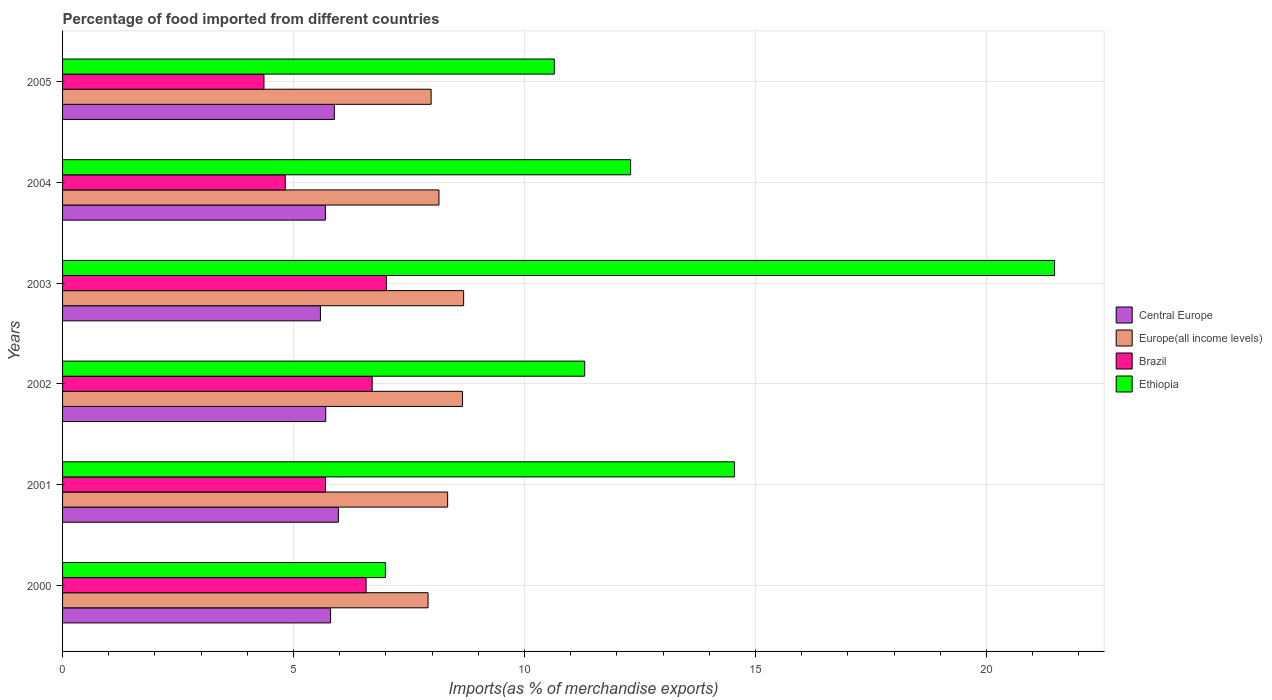How many groups of bars are there?
Keep it short and to the point. 6. Are the number of bars on each tick of the Y-axis equal?
Provide a short and direct response. Yes. How many bars are there on the 4th tick from the top?
Provide a short and direct response. 4. How many bars are there on the 3rd tick from the bottom?
Keep it short and to the point. 4. What is the label of the 4th group of bars from the top?
Make the answer very short. 2002. What is the percentage of imports to different countries in Europe(all income levels) in 2001?
Offer a very short reply. 8.34. Across all years, what is the maximum percentage of imports to different countries in Ethiopia?
Offer a very short reply. 21.47. Across all years, what is the minimum percentage of imports to different countries in Brazil?
Your response must be concise. 4.36. What is the total percentage of imports to different countries in Europe(all income levels) in the graph?
Your answer should be compact. 49.71. What is the difference between the percentage of imports to different countries in Ethiopia in 2002 and that in 2004?
Provide a succinct answer. -0.99. What is the difference between the percentage of imports to different countries in Europe(all income levels) in 2005 and the percentage of imports to different countries in Central Europe in 2000?
Provide a short and direct response. 2.18. What is the average percentage of imports to different countries in Central Europe per year?
Keep it short and to the point. 5.77. In the year 2004, what is the difference between the percentage of imports to different countries in Ethiopia and percentage of imports to different countries in Central Europe?
Keep it short and to the point. 6.61. What is the ratio of the percentage of imports to different countries in Ethiopia in 2001 to that in 2002?
Your answer should be very brief. 1.29. Is the percentage of imports to different countries in Europe(all income levels) in 2002 less than that in 2004?
Provide a short and direct response. No. Is the difference between the percentage of imports to different countries in Ethiopia in 2002 and 2005 greater than the difference between the percentage of imports to different countries in Central Europe in 2002 and 2005?
Ensure brevity in your answer.  Yes. What is the difference between the highest and the second highest percentage of imports to different countries in Europe(all income levels)?
Make the answer very short. 0.03. What is the difference between the highest and the lowest percentage of imports to different countries in Ethiopia?
Provide a succinct answer. 14.49. Is it the case that in every year, the sum of the percentage of imports to different countries in Brazil and percentage of imports to different countries in Ethiopia is greater than the sum of percentage of imports to different countries in Europe(all income levels) and percentage of imports to different countries in Central Europe?
Provide a short and direct response. Yes. What does the 4th bar from the top in 2004 represents?
Offer a terse response. Central Europe. What does the 2nd bar from the bottom in 2004 represents?
Offer a very short reply. Europe(all income levels). Is it the case that in every year, the sum of the percentage of imports to different countries in Europe(all income levels) and percentage of imports to different countries in Brazil is greater than the percentage of imports to different countries in Ethiopia?
Provide a succinct answer. No. Are all the bars in the graph horizontal?
Provide a short and direct response. Yes. How many years are there in the graph?
Offer a terse response. 6. What is the difference between two consecutive major ticks on the X-axis?
Provide a short and direct response. 5. Are the values on the major ticks of X-axis written in scientific E-notation?
Your response must be concise. No. Does the graph contain any zero values?
Provide a succinct answer. No. How many legend labels are there?
Offer a very short reply. 4. What is the title of the graph?
Your answer should be very brief. Percentage of food imported from different countries. What is the label or title of the X-axis?
Ensure brevity in your answer.  Imports(as % of merchandise exports). What is the Imports(as % of merchandise exports) in Central Europe in 2000?
Ensure brevity in your answer.  5.8. What is the Imports(as % of merchandise exports) of Europe(all income levels) in 2000?
Provide a succinct answer. 7.91. What is the Imports(as % of merchandise exports) in Brazil in 2000?
Provide a succinct answer. 6.57. What is the Imports(as % of merchandise exports) in Ethiopia in 2000?
Your answer should be very brief. 6.99. What is the Imports(as % of merchandise exports) in Central Europe in 2001?
Offer a very short reply. 5.97. What is the Imports(as % of merchandise exports) of Europe(all income levels) in 2001?
Your answer should be very brief. 8.34. What is the Imports(as % of merchandise exports) of Brazil in 2001?
Ensure brevity in your answer.  5.69. What is the Imports(as % of merchandise exports) of Ethiopia in 2001?
Keep it short and to the point. 14.55. What is the Imports(as % of merchandise exports) of Central Europe in 2002?
Provide a succinct answer. 5.7. What is the Imports(as % of merchandise exports) in Europe(all income levels) in 2002?
Give a very brief answer. 8.66. What is the Imports(as % of merchandise exports) in Brazil in 2002?
Give a very brief answer. 6.7. What is the Imports(as % of merchandise exports) of Ethiopia in 2002?
Provide a succinct answer. 11.3. What is the Imports(as % of merchandise exports) of Central Europe in 2003?
Keep it short and to the point. 5.58. What is the Imports(as % of merchandise exports) in Europe(all income levels) in 2003?
Offer a very short reply. 8.68. What is the Imports(as % of merchandise exports) of Brazil in 2003?
Offer a very short reply. 7.01. What is the Imports(as % of merchandise exports) of Ethiopia in 2003?
Provide a succinct answer. 21.47. What is the Imports(as % of merchandise exports) in Central Europe in 2004?
Your answer should be compact. 5.69. What is the Imports(as % of merchandise exports) in Europe(all income levels) in 2004?
Offer a very short reply. 8.15. What is the Imports(as % of merchandise exports) of Brazil in 2004?
Keep it short and to the point. 4.82. What is the Imports(as % of merchandise exports) in Ethiopia in 2004?
Ensure brevity in your answer.  12.3. What is the Imports(as % of merchandise exports) of Central Europe in 2005?
Your answer should be compact. 5.88. What is the Imports(as % of merchandise exports) of Europe(all income levels) in 2005?
Offer a very short reply. 7.98. What is the Imports(as % of merchandise exports) of Brazil in 2005?
Provide a short and direct response. 4.36. What is the Imports(as % of merchandise exports) of Ethiopia in 2005?
Give a very brief answer. 10.64. Across all years, what is the maximum Imports(as % of merchandise exports) in Central Europe?
Provide a succinct answer. 5.97. Across all years, what is the maximum Imports(as % of merchandise exports) of Europe(all income levels)?
Make the answer very short. 8.68. Across all years, what is the maximum Imports(as % of merchandise exports) in Brazil?
Your answer should be very brief. 7.01. Across all years, what is the maximum Imports(as % of merchandise exports) in Ethiopia?
Keep it short and to the point. 21.47. Across all years, what is the minimum Imports(as % of merchandise exports) of Central Europe?
Keep it short and to the point. 5.58. Across all years, what is the minimum Imports(as % of merchandise exports) in Europe(all income levels)?
Your response must be concise. 7.91. Across all years, what is the minimum Imports(as % of merchandise exports) of Brazil?
Your answer should be compact. 4.36. Across all years, what is the minimum Imports(as % of merchandise exports) of Ethiopia?
Provide a short and direct response. 6.99. What is the total Imports(as % of merchandise exports) in Central Europe in the graph?
Your answer should be compact. 34.62. What is the total Imports(as % of merchandise exports) in Europe(all income levels) in the graph?
Keep it short and to the point. 49.71. What is the total Imports(as % of merchandise exports) in Brazil in the graph?
Offer a terse response. 35.16. What is the total Imports(as % of merchandise exports) in Ethiopia in the graph?
Make the answer very short. 77.26. What is the difference between the Imports(as % of merchandise exports) of Central Europe in 2000 and that in 2001?
Offer a very short reply. -0.17. What is the difference between the Imports(as % of merchandise exports) in Europe(all income levels) in 2000 and that in 2001?
Your answer should be very brief. -0.42. What is the difference between the Imports(as % of merchandise exports) of Brazil in 2000 and that in 2001?
Offer a terse response. 0.88. What is the difference between the Imports(as % of merchandise exports) of Ethiopia in 2000 and that in 2001?
Offer a very short reply. -7.56. What is the difference between the Imports(as % of merchandise exports) in Central Europe in 2000 and that in 2002?
Offer a terse response. 0.1. What is the difference between the Imports(as % of merchandise exports) of Europe(all income levels) in 2000 and that in 2002?
Provide a short and direct response. -0.74. What is the difference between the Imports(as % of merchandise exports) in Brazil in 2000 and that in 2002?
Give a very brief answer. -0.13. What is the difference between the Imports(as % of merchandise exports) of Ethiopia in 2000 and that in 2002?
Your answer should be very brief. -4.31. What is the difference between the Imports(as % of merchandise exports) of Central Europe in 2000 and that in 2003?
Keep it short and to the point. 0.22. What is the difference between the Imports(as % of merchandise exports) of Europe(all income levels) in 2000 and that in 2003?
Your response must be concise. -0.77. What is the difference between the Imports(as % of merchandise exports) in Brazil in 2000 and that in 2003?
Keep it short and to the point. -0.44. What is the difference between the Imports(as % of merchandise exports) of Ethiopia in 2000 and that in 2003?
Offer a very short reply. -14.49. What is the difference between the Imports(as % of merchandise exports) of Central Europe in 2000 and that in 2004?
Ensure brevity in your answer.  0.11. What is the difference between the Imports(as % of merchandise exports) of Europe(all income levels) in 2000 and that in 2004?
Offer a terse response. -0.24. What is the difference between the Imports(as % of merchandise exports) in Brazil in 2000 and that in 2004?
Provide a succinct answer. 1.75. What is the difference between the Imports(as % of merchandise exports) in Ethiopia in 2000 and that in 2004?
Your answer should be very brief. -5.31. What is the difference between the Imports(as % of merchandise exports) in Central Europe in 2000 and that in 2005?
Offer a very short reply. -0.08. What is the difference between the Imports(as % of merchandise exports) of Europe(all income levels) in 2000 and that in 2005?
Ensure brevity in your answer.  -0.07. What is the difference between the Imports(as % of merchandise exports) of Brazil in 2000 and that in 2005?
Give a very brief answer. 2.21. What is the difference between the Imports(as % of merchandise exports) in Ethiopia in 2000 and that in 2005?
Keep it short and to the point. -3.66. What is the difference between the Imports(as % of merchandise exports) of Central Europe in 2001 and that in 2002?
Your answer should be very brief. 0.27. What is the difference between the Imports(as % of merchandise exports) in Europe(all income levels) in 2001 and that in 2002?
Offer a terse response. -0.32. What is the difference between the Imports(as % of merchandise exports) of Brazil in 2001 and that in 2002?
Offer a terse response. -1.01. What is the difference between the Imports(as % of merchandise exports) in Ethiopia in 2001 and that in 2002?
Ensure brevity in your answer.  3.24. What is the difference between the Imports(as % of merchandise exports) in Central Europe in 2001 and that in 2003?
Your answer should be compact. 0.39. What is the difference between the Imports(as % of merchandise exports) of Europe(all income levels) in 2001 and that in 2003?
Provide a short and direct response. -0.35. What is the difference between the Imports(as % of merchandise exports) of Brazil in 2001 and that in 2003?
Make the answer very short. -1.32. What is the difference between the Imports(as % of merchandise exports) of Ethiopia in 2001 and that in 2003?
Your answer should be very brief. -6.93. What is the difference between the Imports(as % of merchandise exports) of Central Europe in 2001 and that in 2004?
Your answer should be compact. 0.28. What is the difference between the Imports(as % of merchandise exports) in Europe(all income levels) in 2001 and that in 2004?
Offer a very short reply. 0.19. What is the difference between the Imports(as % of merchandise exports) of Brazil in 2001 and that in 2004?
Provide a succinct answer. 0.87. What is the difference between the Imports(as % of merchandise exports) of Ethiopia in 2001 and that in 2004?
Your response must be concise. 2.25. What is the difference between the Imports(as % of merchandise exports) in Central Europe in 2001 and that in 2005?
Offer a terse response. 0.09. What is the difference between the Imports(as % of merchandise exports) of Europe(all income levels) in 2001 and that in 2005?
Provide a short and direct response. 0.36. What is the difference between the Imports(as % of merchandise exports) of Brazil in 2001 and that in 2005?
Your response must be concise. 1.33. What is the difference between the Imports(as % of merchandise exports) of Ethiopia in 2001 and that in 2005?
Your answer should be compact. 3.9. What is the difference between the Imports(as % of merchandise exports) in Central Europe in 2002 and that in 2003?
Offer a terse response. 0.12. What is the difference between the Imports(as % of merchandise exports) in Europe(all income levels) in 2002 and that in 2003?
Your answer should be very brief. -0.03. What is the difference between the Imports(as % of merchandise exports) of Brazil in 2002 and that in 2003?
Give a very brief answer. -0.31. What is the difference between the Imports(as % of merchandise exports) in Ethiopia in 2002 and that in 2003?
Make the answer very short. -10.17. What is the difference between the Imports(as % of merchandise exports) of Central Europe in 2002 and that in 2004?
Your response must be concise. 0.01. What is the difference between the Imports(as % of merchandise exports) in Europe(all income levels) in 2002 and that in 2004?
Give a very brief answer. 0.51. What is the difference between the Imports(as % of merchandise exports) of Brazil in 2002 and that in 2004?
Offer a very short reply. 1.88. What is the difference between the Imports(as % of merchandise exports) of Ethiopia in 2002 and that in 2004?
Your answer should be compact. -0.99. What is the difference between the Imports(as % of merchandise exports) of Central Europe in 2002 and that in 2005?
Keep it short and to the point. -0.19. What is the difference between the Imports(as % of merchandise exports) in Europe(all income levels) in 2002 and that in 2005?
Your answer should be compact. 0.68. What is the difference between the Imports(as % of merchandise exports) in Brazil in 2002 and that in 2005?
Ensure brevity in your answer.  2.34. What is the difference between the Imports(as % of merchandise exports) in Ethiopia in 2002 and that in 2005?
Make the answer very short. 0.66. What is the difference between the Imports(as % of merchandise exports) in Central Europe in 2003 and that in 2004?
Provide a succinct answer. -0.11. What is the difference between the Imports(as % of merchandise exports) in Europe(all income levels) in 2003 and that in 2004?
Offer a very short reply. 0.53. What is the difference between the Imports(as % of merchandise exports) of Brazil in 2003 and that in 2004?
Offer a very short reply. 2.19. What is the difference between the Imports(as % of merchandise exports) in Ethiopia in 2003 and that in 2004?
Keep it short and to the point. 9.18. What is the difference between the Imports(as % of merchandise exports) in Central Europe in 2003 and that in 2005?
Provide a short and direct response. -0.3. What is the difference between the Imports(as % of merchandise exports) in Europe(all income levels) in 2003 and that in 2005?
Give a very brief answer. 0.7. What is the difference between the Imports(as % of merchandise exports) in Brazil in 2003 and that in 2005?
Your answer should be very brief. 2.65. What is the difference between the Imports(as % of merchandise exports) in Ethiopia in 2003 and that in 2005?
Keep it short and to the point. 10.83. What is the difference between the Imports(as % of merchandise exports) in Central Europe in 2004 and that in 2005?
Provide a short and direct response. -0.19. What is the difference between the Imports(as % of merchandise exports) in Europe(all income levels) in 2004 and that in 2005?
Keep it short and to the point. 0.17. What is the difference between the Imports(as % of merchandise exports) in Brazil in 2004 and that in 2005?
Give a very brief answer. 0.46. What is the difference between the Imports(as % of merchandise exports) of Ethiopia in 2004 and that in 2005?
Provide a short and direct response. 1.65. What is the difference between the Imports(as % of merchandise exports) in Central Europe in 2000 and the Imports(as % of merchandise exports) in Europe(all income levels) in 2001?
Make the answer very short. -2.53. What is the difference between the Imports(as % of merchandise exports) of Central Europe in 2000 and the Imports(as % of merchandise exports) of Brazil in 2001?
Provide a succinct answer. 0.11. What is the difference between the Imports(as % of merchandise exports) in Central Europe in 2000 and the Imports(as % of merchandise exports) in Ethiopia in 2001?
Your answer should be very brief. -8.74. What is the difference between the Imports(as % of merchandise exports) in Europe(all income levels) in 2000 and the Imports(as % of merchandise exports) in Brazil in 2001?
Your answer should be compact. 2.22. What is the difference between the Imports(as % of merchandise exports) in Europe(all income levels) in 2000 and the Imports(as % of merchandise exports) in Ethiopia in 2001?
Keep it short and to the point. -6.63. What is the difference between the Imports(as % of merchandise exports) of Brazil in 2000 and the Imports(as % of merchandise exports) of Ethiopia in 2001?
Make the answer very short. -7.98. What is the difference between the Imports(as % of merchandise exports) in Central Europe in 2000 and the Imports(as % of merchandise exports) in Europe(all income levels) in 2002?
Ensure brevity in your answer.  -2.85. What is the difference between the Imports(as % of merchandise exports) of Central Europe in 2000 and the Imports(as % of merchandise exports) of Brazil in 2002?
Keep it short and to the point. -0.9. What is the difference between the Imports(as % of merchandise exports) of Central Europe in 2000 and the Imports(as % of merchandise exports) of Ethiopia in 2002?
Your answer should be very brief. -5.5. What is the difference between the Imports(as % of merchandise exports) of Europe(all income levels) in 2000 and the Imports(as % of merchandise exports) of Brazil in 2002?
Give a very brief answer. 1.21. What is the difference between the Imports(as % of merchandise exports) in Europe(all income levels) in 2000 and the Imports(as % of merchandise exports) in Ethiopia in 2002?
Offer a terse response. -3.39. What is the difference between the Imports(as % of merchandise exports) of Brazil in 2000 and the Imports(as % of merchandise exports) of Ethiopia in 2002?
Provide a succinct answer. -4.73. What is the difference between the Imports(as % of merchandise exports) in Central Europe in 2000 and the Imports(as % of merchandise exports) in Europe(all income levels) in 2003?
Offer a terse response. -2.88. What is the difference between the Imports(as % of merchandise exports) in Central Europe in 2000 and the Imports(as % of merchandise exports) in Brazil in 2003?
Your answer should be compact. -1.21. What is the difference between the Imports(as % of merchandise exports) of Central Europe in 2000 and the Imports(as % of merchandise exports) of Ethiopia in 2003?
Give a very brief answer. -15.67. What is the difference between the Imports(as % of merchandise exports) of Europe(all income levels) in 2000 and the Imports(as % of merchandise exports) of Brazil in 2003?
Your response must be concise. 0.9. What is the difference between the Imports(as % of merchandise exports) of Europe(all income levels) in 2000 and the Imports(as % of merchandise exports) of Ethiopia in 2003?
Provide a succinct answer. -13.56. What is the difference between the Imports(as % of merchandise exports) of Brazil in 2000 and the Imports(as % of merchandise exports) of Ethiopia in 2003?
Give a very brief answer. -14.9. What is the difference between the Imports(as % of merchandise exports) in Central Europe in 2000 and the Imports(as % of merchandise exports) in Europe(all income levels) in 2004?
Offer a very short reply. -2.35. What is the difference between the Imports(as % of merchandise exports) in Central Europe in 2000 and the Imports(as % of merchandise exports) in Brazil in 2004?
Provide a short and direct response. 0.98. What is the difference between the Imports(as % of merchandise exports) in Central Europe in 2000 and the Imports(as % of merchandise exports) in Ethiopia in 2004?
Provide a succinct answer. -6.5. What is the difference between the Imports(as % of merchandise exports) of Europe(all income levels) in 2000 and the Imports(as % of merchandise exports) of Brazil in 2004?
Ensure brevity in your answer.  3.09. What is the difference between the Imports(as % of merchandise exports) of Europe(all income levels) in 2000 and the Imports(as % of merchandise exports) of Ethiopia in 2004?
Ensure brevity in your answer.  -4.39. What is the difference between the Imports(as % of merchandise exports) in Brazil in 2000 and the Imports(as % of merchandise exports) in Ethiopia in 2004?
Your answer should be very brief. -5.73. What is the difference between the Imports(as % of merchandise exports) of Central Europe in 2000 and the Imports(as % of merchandise exports) of Europe(all income levels) in 2005?
Your response must be concise. -2.18. What is the difference between the Imports(as % of merchandise exports) of Central Europe in 2000 and the Imports(as % of merchandise exports) of Brazil in 2005?
Make the answer very short. 1.44. What is the difference between the Imports(as % of merchandise exports) of Central Europe in 2000 and the Imports(as % of merchandise exports) of Ethiopia in 2005?
Your answer should be very brief. -4.84. What is the difference between the Imports(as % of merchandise exports) in Europe(all income levels) in 2000 and the Imports(as % of merchandise exports) in Brazil in 2005?
Provide a short and direct response. 3.55. What is the difference between the Imports(as % of merchandise exports) of Europe(all income levels) in 2000 and the Imports(as % of merchandise exports) of Ethiopia in 2005?
Your response must be concise. -2.73. What is the difference between the Imports(as % of merchandise exports) in Brazil in 2000 and the Imports(as % of merchandise exports) in Ethiopia in 2005?
Offer a terse response. -4.07. What is the difference between the Imports(as % of merchandise exports) in Central Europe in 2001 and the Imports(as % of merchandise exports) in Europe(all income levels) in 2002?
Provide a succinct answer. -2.69. What is the difference between the Imports(as % of merchandise exports) in Central Europe in 2001 and the Imports(as % of merchandise exports) in Brazil in 2002?
Provide a short and direct response. -0.73. What is the difference between the Imports(as % of merchandise exports) of Central Europe in 2001 and the Imports(as % of merchandise exports) of Ethiopia in 2002?
Ensure brevity in your answer.  -5.33. What is the difference between the Imports(as % of merchandise exports) of Europe(all income levels) in 2001 and the Imports(as % of merchandise exports) of Brazil in 2002?
Your answer should be very brief. 1.63. What is the difference between the Imports(as % of merchandise exports) of Europe(all income levels) in 2001 and the Imports(as % of merchandise exports) of Ethiopia in 2002?
Provide a succinct answer. -2.97. What is the difference between the Imports(as % of merchandise exports) of Brazil in 2001 and the Imports(as % of merchandise exports) of Ethiopia in 2002?
Offer a terse response. -5.61. What is the difference between the Imports(as % of merchandise exports) in Central Europe in 2001 and the Imports(as % of merchandise exports) in Europe(all income levels) in 2003?
Keep it short and to the point. -2.71. What is the difference between the Imports(as % of merchandise exports) in Central Europe in 2001 and the Imports(as % of merchandise exports) in Brazil in 2003?
Your answer should be compact. -1.04. What is the difference between the Imports(as % of merchandise exports) in Central Europe in 2001 and the Imports(as % of merchandise exports) in Ethiopia in 2003?
Your answer should be compact. -15.5. What is the difference between the Imports(as % of merchandise exports) in Europe(all income levels) in 2001 and the Imports(as % of merchandise exports) in Brazil in 2003?
Your answer should be compact. 1.33. What is the difference between the Imports(as % of merchandise exports) of Europe(all income levels) in 2001 and the Imports(as % of merchandise exports) of Ethiopia in 2003?
Offer a terse response. -13.14. What is the difference between the Imports(as % of merchandise exports) of Brazil in 2001 and the Imports(as % of merchandise exports) of Ethiopia in 2003?
Your answer should be compact. -15.78. What is the difference between the Imports(as % of merchandise exports) in Central Europe in 2001 and the Imports(as % of merchandise exports) in Europe(all income levels) in 2004?
Your response must be concise. -2.18. What is the difference between the Imports(as % of merchandise exports) of Central Europe in 2001 and the Imports(as % of merchandise exports) of Brazil in 2004?
Make the answer very short. 1.15. What is the difference between the Imports(as % of merchandise exports) in Central Europe in 2001 and the Imports(as % of merchandise exports) in Ethiopia in 2004?
Ensure brevity in your answer.  -6.33. What is the difference between the Imports(as % of merchandise exports) in Europe(all income levels) in 2001 and the Imports(as % of merchandise exports) in Brazil in 2004?
Provide a succinct answer. 3.52. What is the difference between the Imports(as % of merchandise exports) in Europe(all income levels) in 2001 and the Imports(as % of merchandise exports) in Ethiopia in 2004?
Ensure brevity in your answer.  -3.96. What is the difference between the Imports(as % of merchandise exports) in Brazil in 2001 and the Imports(as % of merchandise exports) in Ethiopia in 2004?
Ensure brevity in your answer.  -6.61. What is the difference between the Imports(as % of merchandise exports) in Central Europe in 2001 and the Imports(as % of merchandise exports) in Europe(all income levels) in 2005?
Provide a short and direct response. -2.01. What is the difference between the Imports(as % of merchandise exports) of Central Europe in 2001 and the Imports(as % of merchandise exports) of Brazil in 2005?
Make the answer very short. 1.61. What is the difference between the Imports(as % of merchandise exports) in Central Europe in 2001 and the Imports(as % of merchandise exports) in Ethiopia in 2005?
Provide a succinct answer. -4.67. What is the difference between the Imports(as % of merchandise exports) in Europe(all income levels) in 2001 and the Imports(as % of merchandise exports) in Brazil in 2005?
Give a very brief answer. 3.98. What is the difference between the Imports(as % of merchandise exports) in Europe(all income levels) in 2001 and the Imports(as % of merchandise exports) in Ethiopia in 2005?
Provide a short and direct response. -2.31. What is the difference between the Imports(as % of merchandise exports) in Brazil in 2001 and the Imports(as % of merchandise exports) in Ethiopia in 2005?
Your response must be concise. -4.95. What is the difference between the Imports(as % of merchandise exports) of Central Europe in 2002 and the Imports(as % of merchandise exports) of Europe(all income levels) in 2003?
Give a very brief answer. -2.98. What is the difference between the Imports(as % of merchandise exports) in Central Europe in 2002 and the Imports(as % of merchandise exports) in Brazil in 2003?
Your response must be concise. -1.31. What is the difference between the Imports(as % of merchandise exports) of Central Europe in 2002 and the Imports(as % of merchandise exports) of Ethiopia in 2003?
Your response must be concise. -15.78. What is the difference between the Imports(as % of merchandise exports) of Europe(all income levels) in 2002 and the Imports(as % of merchandise exports) of Brazil in 2003?
Your answer should be compact. 1.65. What is the difference between the Imports(as % of merchandise exports) of Europe(all income levels) in 2002 and the Imports(as % of merchandise exports) of Ethiopia in 2003?
Your answer should be compact. -12.82. What is the difference between the Imports(as % of merchandise exports) in Brazil in 2002 and the Imports(as % of merchandise exports) in Ethiopia in 2003?
Offer a very short reply. -14.77. What is the difference between the Imports(as % of merchandise exports) of Central Europe in 2002 and the Imports(as % of merchandise exports) of Europe(all income levels) in 2004?
Offer a terse response. -2.45. What is the difference between the Imports(as % of merchandise exports) of Central Europe in 2002 and the Imports(as % of merchandise exports) of Brazil in 2004?
Your response must be concise. 0.88. What is the difference between the Imports(as % of merchandise exports) of Central Europe in 2002 and the Imports(as % of merchandise exports) of Ethiopia in 2004?
Provide a short and direct response. -6.6. What is the difference between the Imports(as % of merchandise exports) in Europe(all income levels) in 2002 and the Imports(as % of merchandise exports) in Brazil in 2004?
Ensure brevity in your answer.  3.84. What is the difference between the Imports(as % of merchandise exports) of Europe(all income levels) in 2002 and the Imports(as % of merchandise exports) of Ethiopia in 2004?
Give a very brief answer. -3.64. What is the difference between the Imports(as % of merchandise exports) of Brazil in 2002 and the Imports(as % of merchandise exports) of Ethiopia in 2004?
Your response must be concise. -5.59. What is the difference between the Imports(as % of merchandise exports) of Central Europe in 2002 and the Imports(as % of merchandise exports) of Europe(all income levels) in 2005?
Keep it short and to the point. -2.28. What is the difference between the Imports(as % of merchandise exports) in Central Europe in 2002 and the Imports(as % of merchandise exports) in Brazil in 2005?
Your answer should be very brief. 1.34. What is the difference between the Imports(as % of merchandise exports) in Central Europe in 2002 and the Imports(as % of merchandise exports) in Ethiopia in 2005?
Give a very brief answer. -4.95. What is the difference between the Imports(as % of merchandise exports) in Europe(all income levels) in 2002 and the Imports(as % of merchandise exports) in Brazil in 2005?
Offer a terse response. 4.3. What is the difference between the Imports(as % of merchandise exports) in Europe(all income levels) in 2002 and the Imports(as % of merchandise exports) in Ethiopia in 2005?
Offer a terse response. -1.99. What is the difference between the Imports(as % of merchandise exports) of Brazil in 2002 and the Imports(as % of merchandise exports) of Ethiopia in 2005?
Keep it short and to the point. -3.94. What is the difference between the Imports(as % of merchandise exports) in Central Europe in 2003 and the Imports(as % of merchandise exports) in Europe(all income levels) in 2004?
Your response must be concise. -2.57. What is the difference between the Imports(as % of merchandise exports) of Central Europe in 2003 and the Imports(as % of merchandise exports) of Brazil in 2004?
Offer a terse response. 0.76. What is the difference between the Imports(as % of merchandise exports) of Central Europe in 2003 and the Imports(as % of merchandise exports) of Ethiopia in 2004?
Offer a terse response. -6.72. What is the difference between the Imports(as % of merchandise exports) in Europe(all income levels) in 2003 and the Imports(as % of merchandise exports) in Brazil in 2004?
Ensure brevity in your answer.  3.86. What is the difference between the Imports(as % of merchandise exports) of Europe(all income levels) in 2003 and the Imports(as % of merchandise exports) of Ethiopia in 2004?
Your response must be concise. -3.61. What is the difference between the Imports(as % of merchandise exports) of Brazil in 2003 and the Imports(as % of merchandise exports) of Ethiopia in 2004?
Give a very brief answer. -5.29. What is the difference between the Imports(as % of merchandise exports) of Central Europe in 2003 and the Imports(as % of merchandise exports) of Europe(all income levels) in 2005?
Give a very brief answer. -2.4. What is the difference between the Imports(as % of merchandise exports) of Central Europe in 2003 and the Imports(as % of merchandise exports) of Brazil in 2005?
Ensure brevity in your answer.  1.22. What is the difference between the Imports(as % of merchandise exports) of Central Europe in 2003 and the Imports(as % of merchandise exports) of Ethiopia in 2005?
Your answer should be compact. -5.06. What is the difference between the Imports(as % of merchandise exports) in Europe(all income levels) in 2003 and the Imports(as % of merchandise exports) in Brazil in 2005?
Keep it short and to the point. 4.32. What is the difference between the Imports(as % of merchandise exports) of Europe(all income levels) in 2003 and the Imports(as % of merchandise exports) of Ethiopia in 2005?
Offer a terse response. -1.96. What is the difference between the Imports(as % of merchandise exports) in Brazil in 2003 and the Imports(as % of merchandise exports) in Ethiopia in 2005?
Ensure brevity in your answer.  -3.63. What is the difference between the Imports(as % of merchandise exports) of Central Europe in 2004 and the Imports(as % of merchandise exports) of Europe(all income levels) in 2005?
Your response must be concise. -2.29. What is the difference between the Imports(as % of merchandise exports) in Central Europe in 2004 and the Imports(as % of merchandise exports) in Brazil in 2005?
Keep it short and to the point. 1.33. What is the difference between the Imports(as % of merchandise exports) in Central Europe in 2004 and the Imports(as % of merchandise exports) in Ethiopia in 2005?
Give a very brief answer. -4.96. What is the difference between the Imports(as % of merchandise exports) of Europe(all income levels) in 2004 and the Imports(as % of merchandise exports) of Brazil in 2005?
Your answer should be very brief. 3.79. What is the difference between the Imports(as % of merchandise exports) of Europe(all income levels) in 2004 and the Imports(as % of merchandise exports) of Ethiopia in 2005?
Provide a succinct answer. -2.5. What is the difference between the Imports(as % of merchandise exports) of Brazil in 2004 and the Imports(as % of merchandise exports) of Ethiopia in 2005?
Your answer should be compact. -5.82. What is the average Imports(as % of merchandise exports) of Central Europe per year?
Make the answer very short. 5.77. What is the average Imports(as % of merchandise exports) of Europe(all income levels) per year?
Make the answer very short. 8.29. What is the average Imports(as % of merchandise exports) in Brazil per year?
Keep it short and to the point. 5.86. What is the average Imports(as % of merchandise exports) in Ethiopia per year?
Offer a very short reply. 12.88. In the year 2000, what is the difference between the Imports(as % of merchandise exports) in Central Europe and Imports(as % of merchandise exports) in Europe(all income levels)?
Keep it short and to the point. -2.11. In the year 2000, what is the difference between the Imports(as % of merchandise exports) in Central Europe and Imports(as % of merchandise exports) in Brazil?
Offer a terse response. -0.77. In the year 2000, what is the difference between the Imports(as % of merchandise exports) in Central Europe and Imports(as % of merchandise exports) in Ethiopia?
Offer a terse response. -1.19. In the year 2000, what is the difference between the Imports(as % of merchandise exports) of Europe(all income levels) and Imports(as % of merchandise exports) of Brazil?
Give a very brief answer. 1.34. In the year 2000, what is the difference between the Imports(as % of merchandise exports) of Europe(all income levels) and Imports(as % of merchandise exports) of Ethiopia?
Your response must be concise. 0.92. In the year 2000, what is the difference between the Imports(as % of merchandise exports) of Brazil and Imports(as % of merchandise exports) of Ethiopia?
Give a very brief answer. -0.42. In the year 2001, what is the difference between the Imports(as % of merchandise exports) in Central Europe and Imports(as % of merchandise exports) in Europe(all income levels)?
Keep it short and to the point. -2.37. In the year 2001, what is the difference between the Imports(as % of merchandise exports) of Central Europe and Imports(as % of merchandise exports) of Brazil?
Offer a terse response. 0.28. In the year 2001, what is the difference between the Imports(as % of merchandise exports) in Central Europe and Imports(as % of merchandise exports) in Ethiopia?
Give a very brief answer. -8.58. In the year 2001, what is the difference between the Imports(as % of merchandise exports) in Europe(all income levels) and Imports(as % of merchandise exports) in Brazil?
Give a very brief answer. 2.64. In the year 2001, what is the difference between the Imports(as % of merchandise exports) of Europe(all income levels) and Imports(as % of merchandise exports) of Ethiopia?
Your answer should be very brief. -6.21. In the year 2001, what is the difference between the Imports(as % of merchandise exports) in Brazil and Imports(as % of merchandise exports) in Ethiopia?
Make the answer very short. -8.85. In the year 2002, what is the difference between the Imports(as % of merchandise exports) in Central Europe and Imports(as % of merchandise exports) in Europe(all income levels)?
Your answer should be very brief. -2.96. In the year 2002, what is the difference between the Imports(as % of merchandise exports) in Central Europe and Imports(as % of merchandise exports) in Brazil?
Make the answer very short. -1.01. In the year 2002, what is the difference between the Imports(as % of merchandise exports) in Central Europe and Imports(as % of merchandise exports) in Ethiopia?
Provide a short and direct response. -5.61. In the year 2002, what is the difference between the Imports(as % of merchandise exports) of Europe(all income levels) and Imports(as % of merchandise exports) of Brazil?
Keep it short and to the point. 1.95. In the year 2002, what is the difference between the Imports(as % of merchandise exports) in Europe(all income levels) and Imports(as % of merchandise exports) in Ethiopia?
Offer a very short reply. -2.65. In the year 2002, what is the difference between the Imports(as % of merchandise exports) in Brazil and Imports(as % of merchandise exports) in Ethiopia?
Provide a short and direct response. -4.6. In the year 2003, what is the difference between the Imports(as % of merchandise exports) of Central Europe and Imports(as % of merchandise exports) of Europe(all income levels)?
Your answer should be very brief. -3.1. In the year 2003, what is the difference between the Imports(as % of merchandise exports) of Central Europe and Imports(as % of merchandise exports) of Brazil?
Your answer should be very brief. -1.43. In the year 2003, what is the difference between the Imports(as % of merchandise exports) in Central Europe and Imports(as % of merchandise exports) in Ethiopia?
Provide a short and direct response. -15.89. In the year 2003, what is the difference between the Imports(as % of merchandise exports) in Europe(all income levels) and Imports(as % of merchandise exports) in Brazil?
Offer a terse response. 1.67. In the year 2003, what is the difference between the Imports(as % of merchandise exports) in Europe(all income levels) and Imports(as % of merchandise exports) in Ethiopia?
Your answer should be compact. -12.79. In the year 2003, what is the difference between the Imports(as % of merchandise exports) of Brazil and Imports(as % of merchandise exports) of Ethiopia?
Your answer should be very brief. -14.46. In the year 2004, what is the difference between the Imports(as % of merchandise exports) of Central Europe and Imports(as % of merchandise exports) of Europe(all income levels)?
Make the answer very short. -2.46. In the year 2004, what is the difference between the Imports(as % of merchandise exports) in Central Europe and Imports(as % of merchandise exports) in Brazil?
Offer a very short reply. 0.87. In the year 2004, what is the difference between the Imports(as % of merchandise exports) of Central Europe and Imports(as % of merchandise exports) of Ethiopia?
Ensure brevity in your answer.  -6.61. In the year 2004, what is the difference between the Imports(as % of merchandise exports) in Europe(all income levels) and Imports(as % of merchandise exports) in Brazil?
Keep it short and to the point. 3.33. In the year 2004, what is the difference between the Imports(as % of merchandise exports) in Europe(all income levels) and Imports(as % of merchandise exports) in Ethiopia?
Offer a terse response. -4.15. In the year 2004, what is the difference between the Imports(as % of merchandise exports) of Brazil and Imports(as % of merchandise exports) of Ethiopia?
Your answer should be compact. -7.48. In the year 2005, what is the difference between the Imports(as % of merchandise exports) of Central Europe and Imports(as % of merchandise exports) of Europe(all income levels)?
Make the answer very short. -2.1. In the year 2005, what is the difference between the Imports(as % of merchandise exports) in Central Europe and Imports(as % of merchandise exports) in Brazil?
Offer a very short reply. 1.52. In the year 2005, what is the difference between the Imports(as % of merchandise exports) of Central Europe and Imports(as % of merchandise exports) of Ethiopia?
Offer a very short reply. -4.76. In the year 2005, what is the difference between the Imports(as % of merchandise exports) in Europe(all income levels) and Imports(as % of merchandise exports) in Brazil?
Your answer should be compact. 3.62. In the year 2005, what is the difference between the Imports(as % of merchandise exports) of Europe(all income levels) and Imports(as % of merchandise exports) of Ethiopia?
Your answer should be compact. -2.67. In the year 2005, what is the difference between the Imports(as % of merchandise exports) of Brazil and Imports(as % of merchandise exports) of Ethiopia?
Keep it short and to the point. -6.29. What is the ratio of the Imports(as % of merchandise exports) of Central Europe in 2000 to that in 2001?
Your answer should be compact. 0.97. What is the ratio of the Imports(as % of merchandise exports) in Europe(all income levels) in 2000 to that in 2001?
Keep it short and to the point. 0.95. What is the ratio of the Imports(as % of merchandise exports) in Brazil in 2000 to that in 2001?
Make the answer very short. 1.15. What is the ratio of the Imports(as % of merchandise exports) in Ethiopia in 2000 to that in 2001?
Offer a terse response. 0.48. What is the ratio of the Imports(as % of merchandise exports) of Central Europe in 2000 to that in 2002?
Offer a terse response. 1.02. What is the ratio of the Imports(as % of merchandise exports) of Europe(all income levels) in 2000 to that in 2002?
Your response must be concise. 0.91. What is the ratio of the Imports(as % of merchandise exports) of Brazil in 2000 to that in 2002?
Your answer should be compact. 0.98. What is the ratio of the Imports(as % of merchandise exports) in Ethiopia in 2000 to that in 2002?
Give a very brief answer. 0.62. What is the ratio of the Imports(as % of merchandise exports) in Central Europe in 2000 to that in 2003?
Your response must be concise. 1.04. What is the ratio of the Imports(as % of merchandise exports) in Europe(all income levels) in 2000 to that in 2003?
Ensure brevity in your answer.  0.91. What is the ratio of the Imports(as % of merchandise exports) in Brazil in 2000 to that in 2003?
Make the answer very short. 0.94. What is the ratio of the Imports(as % of merchandise exports) of Ethiopia in 2000 to that in 2003?
Make the answer very short. 0.33. What is the ratio of the Imports(as % of merchandise exports) in Central Europe in 2000 to that in 2004?
Provide a succinct answer. 1.02. What is the ratio of the Imports(as % of merchandise exports) in Europe(all income levels) in 2000 to that in 2004?
Ensure brevity in your answer.  0.97. What is the ratio of the Imports(as % of merchandise exports) of Brazil in 2000 to that in 2004?
Ensure brevity in your answer.  1.36. What is the ratio of the Imports(as % of merchandise exports) of Ethiopia in 2000 to that in 2004?
Keep it short and to the point. 0.57. What is the ratio of the Imports(as % of merchandise exports) of Central Europe in 2000 to that in 2005?
Ensure brevity in your answer.  0.99. What is the ratio of the Imports(as % of merchandise exports) of Europe(all income levels) in 2000 to that in 2005?
Your answer should be very brief. 0.99. What is the ratio of the Imports(as % of merchandise exports) of Brazil in 2000 to that in 2005?
Give a very brief answer. 1.51. What is the ratio of the Imports(as % of merchandise exports) in Ethiopia in 2000 to that in 2005?
Offer a terse response. 0.66. What is the ratio of the Imports(as % of merchandise exports) of Central Europe in 2001 to that in 2002?
Offer a terse response. 1.05. What is the ratio of the Imports(as % of merchandise exports) in Europe(all income levels) in 2001 to that in 2002?
Your answer should be very brief. 0.96. What is the ratio of the Imports(as % of merchandise exports) of Brazil in 2001 to that in 2002?
Offer a terse response. 0.85. What is the ratio of the Imports(as % of merchandise exports) of Ethiopia in 2001 to that in 2002?
Provide a succinct answer. 1.29. What is the ratio of the Imports(as % of merchandise exports) of Central Europe in 2001 to that in 2003?
Keep it short and to the point. 1.07. What is the ratio of the Imports(as % of merchandise exports) of Europe(all income levels) in 2001 to that in 2003?
Offer a terse response. 0.96. What is the ratio of the Imports(as % of merchandise exports) of Brazil in 2001 to that in 2003?
Ensure brevity in your answer.  0.81. What is the ratio of the Imports(as % of merchandise exports) in Ethiopia in 2001 to that in 2003?
Offer a very short reply. 0.68. What is the ratio of the Imports(as % of merchandise exports) of Central Europe in 2001 to that in 2004?
Your answer should be compact. 1.05. What is the ratio of the Imports(as % of merchandise exports) in Europe(all income levels) in 2001 to that in 2004?
Offer a terse response. 1.02. What is the ratio of the Imports(as % of merchandise exports) in Brazil in 2001 to that in 2004?
Keep it short and to the point. 1.18. What is the ratio of the Imports(as % of merchandise exports) in Ethiopia in 2001 to that in 2004?
Ensure brevity in your answer.  1.18. What is the ratio of the Imports(as % of merchandise exports) in Central Europe in 2001 to that in 2005?
Provide a short and direct response. 1.01. What is the ratio of the Imports(as % of merchandise exports) of Europe(all income levels) in 2001 to that in 2005?
Your answer should be compact. 1.04. What is the ratio of the Imports(as % of merchandise exports) in Brazil in 2001 to that in 2005?
Your answer should be very brief. 1.31. What is the ratio of the Imports(as % of merchandise exports) in Ethiopia in 2001 to that in 2005?
Keep it short and to the point. 1.37. What is the ratio of the Imports(as % of merchandise exports) of Central Europe in 2002 to that in 2003?
Your response must be concise. 1.02. What is the ratio of the Imports(as % of merchandise exports) of Brazil in 2002 to that in 2003?
Your answer should be compact. 0.96. What is the ratio of the Imports(as % of merchandise exports) of Ethiopia in 2002 to that in 2003?
Your response must be concise. 0.53. What is the ratio of the Imports(as % of merchandise exports) of Central Europe in 2002 to that in 2004?
Ensure brevity in your answer.  1. What is the ratio of the Imports(as % of merchandise exports) of Europe(all income levels) in 2002 to that in 2004?
Provide a succinct answer. 1.06. What is the ratio of the Imports(as % of merchandise exports) in Brazil in 2002 to that in 2004?
Your answer should be very brief. 1.39. What is the ratio of the Imports(as % of merchandise exports) of Ethiopia in 2002 to that in 2004?
Provide a succinct answer. 0.92. What is the ratio of the Imports(as % of merchandise exports) in Central Europe in 2002 to that in 2005?
Ensure brevity in your answer.  0.97. What is the ratio of the Imports(as % of merchandise exports) in Europe(all income levels) in 2002 to that in 2005?
Offer a very short reply. 1.08. What is the ratio of the Imports(as % of merchandise exports) of Brazil in 2002 to that in 2005?
Your response must be concise. 1.54. What is the ratio of the Imports(as % of merchandise exports) of Ethiopia in 2002 to that in 2005?
Keep it short and to the point. 1.06. What is the ratio of the Imports(as % of merchandise exports) in Central Europe in 2003 to that in 2004?
Keep it short and to the point. 0.98. What is the ratio of the Imports(as % of merchandise exports) in Europe(all income levels) in 2003 to that in 2004?
Make the answer very short. 1.07. What is the ratio of the Imports(as % of merchandise exports) of Brazil in 2003 to that in 2004?
Offer a terse response. 1.45. What is the ratio of the Imports(as % of merchandise exports) of Ethiopia in 2003 to that in 2004?
Provide a short and direct response. 1.75. What is the ratio of the Imports(as % of merchandise exports) in Central Europe in 2003 to that in 2005?
Your answer should be compact. 0.95. What is the ratio of the Imports(as % of merchandise exports) of Europe(all income levels) in 2003 to that in 2005?
Your response must be concise. 1.09. What is the ratio of the Imports(as % of merchandise exports) in Brazil in 2003 to that in 2005?
Offer a very short reply. 1.61. What is the ratio of the Imports(as % of merchandise exports) in Ethiopia in 2003 to that in 2005?
Make the answer very short. 2.02. What is the ratio of the Imports(as % of merchandise exports) of Central Europe in 2004 to that in 2005?
Offer a terse response. 0.97. What is the ratio of the Imports(as % of merchandise exports) of Europe(all income levels) in 2004 to that in 2005?
Keep it short and to the point. 1.02. What is the ratio of the Imports(as % of merchandise exports) of Brazil in 2004 to that in 2005?
Give a very brief answer. 1.11. What is the ratio of the Imports(as % of merchandise exports) in Ethiopia in 2004 to that in 2005?
Offer a very short reply. 1.16. What is the difference between the highest and the second highest Imports(as % of merchandise exports) of Central Europe?
Provide a short and direct response. 0.09. What is the difference between the highest and the second highest Imports(as % of merchandise exports) in Europe(all income levels)?
Give a very brief answer. 0.03. What is the difference between the highest and the second highest Imports(as % of merchandise exports) of Brazil?
Your response must be concise. 0.31. What is the difference between the highest and the second highest Imports(as % of merchandise exports) in Ethiopia?
Offer a terse response. 6.93. What is the difference between the highest and the lowest Imports(as % of merchandise exports) of Central Europe?
Provide a short and direct response. 0.39. What is the difference between the highest and the lowest Imports(as % of merchandise exports) in Europe(all income levels)?
Give a very brief answer. 0.77. What is the difference between the highest and the lowest Imports(as % of merchandise exports) of Brazil?
Give a very brief answer. 2.65. What is the difference between the highest and the lowest Imports(as % of merchandise exports) in Ethiopia?
Ensure brevity in your answer.  14.49. 